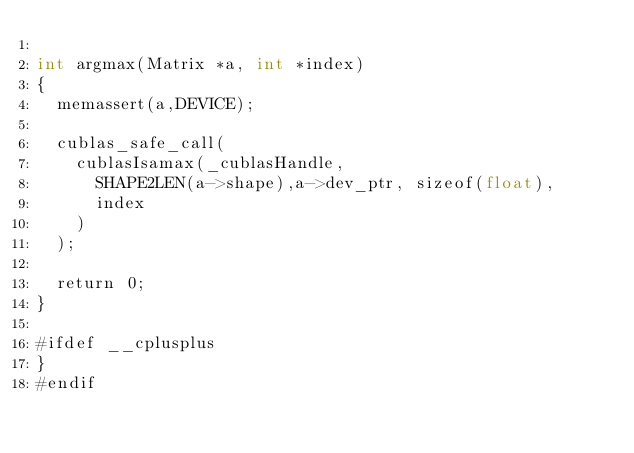<code> <loc_0><loc_0><loc_500><loc_500><_Cuda_>
int argmax(Matrix *a, int *index)
{
  memassert(a,DEVICE);

  cublas_safe_call(
    cublasIsamax(_cublasHandle,
      SHAPE2LEN(a->shape),a->dev_ptr, sizeof(float),
      index
    )
  );

  return 0;
}

#ifdef __cplusplus
}
#endif
</code> 